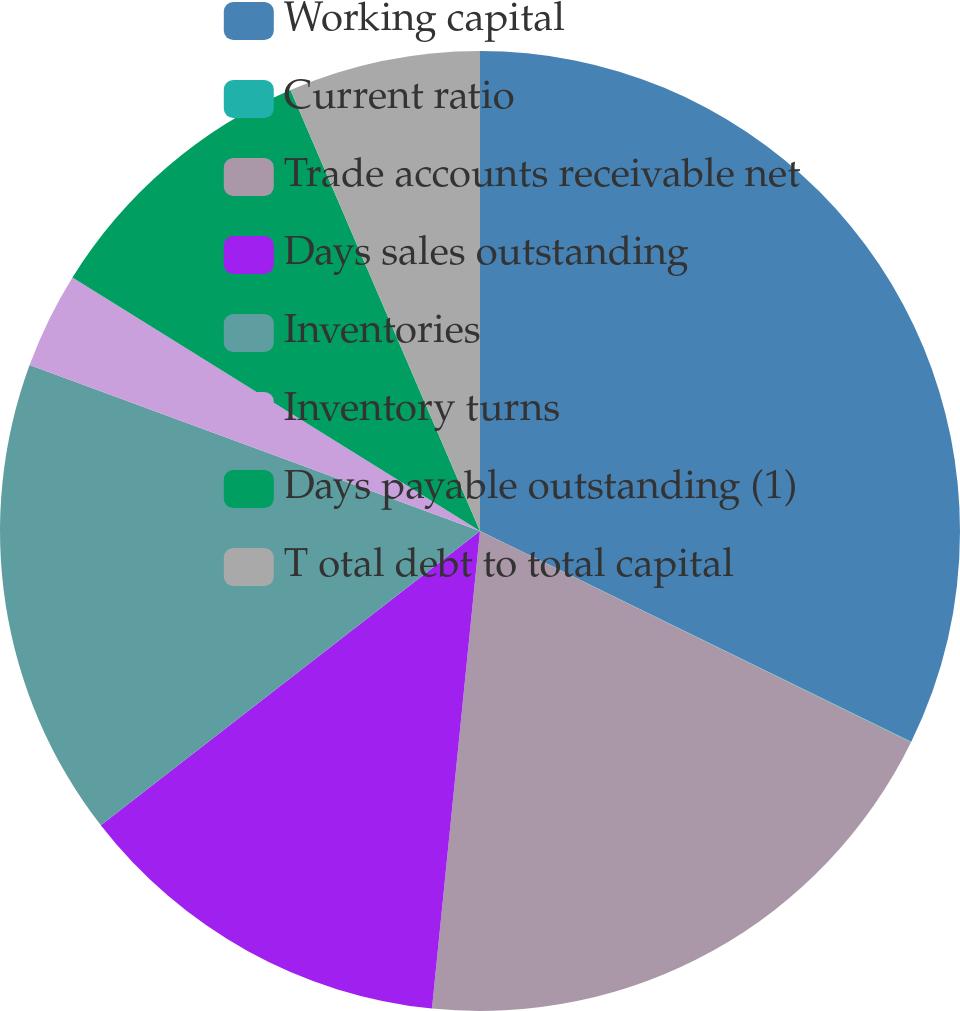Convert chart. <chart><loc_0><loc_0><loc_500><loc_500><pie_chart><fcel>Working capital<fcel>Current ratio<fcel>Trade accounts receivable net<fcel>Days sales outstanding<fcel>Inventories<fcel>Inventory turns<fcel>Days payable outstanding (1)<fcel>T otal debt to total capital<nl><fcel>32.23%<fcel>0.02%<fcel>19.34%<fcel>12.9%<fcel>16.12%<fcel>3.24%<fcel>9.68%<fcel>6.46%<nl></chart> 